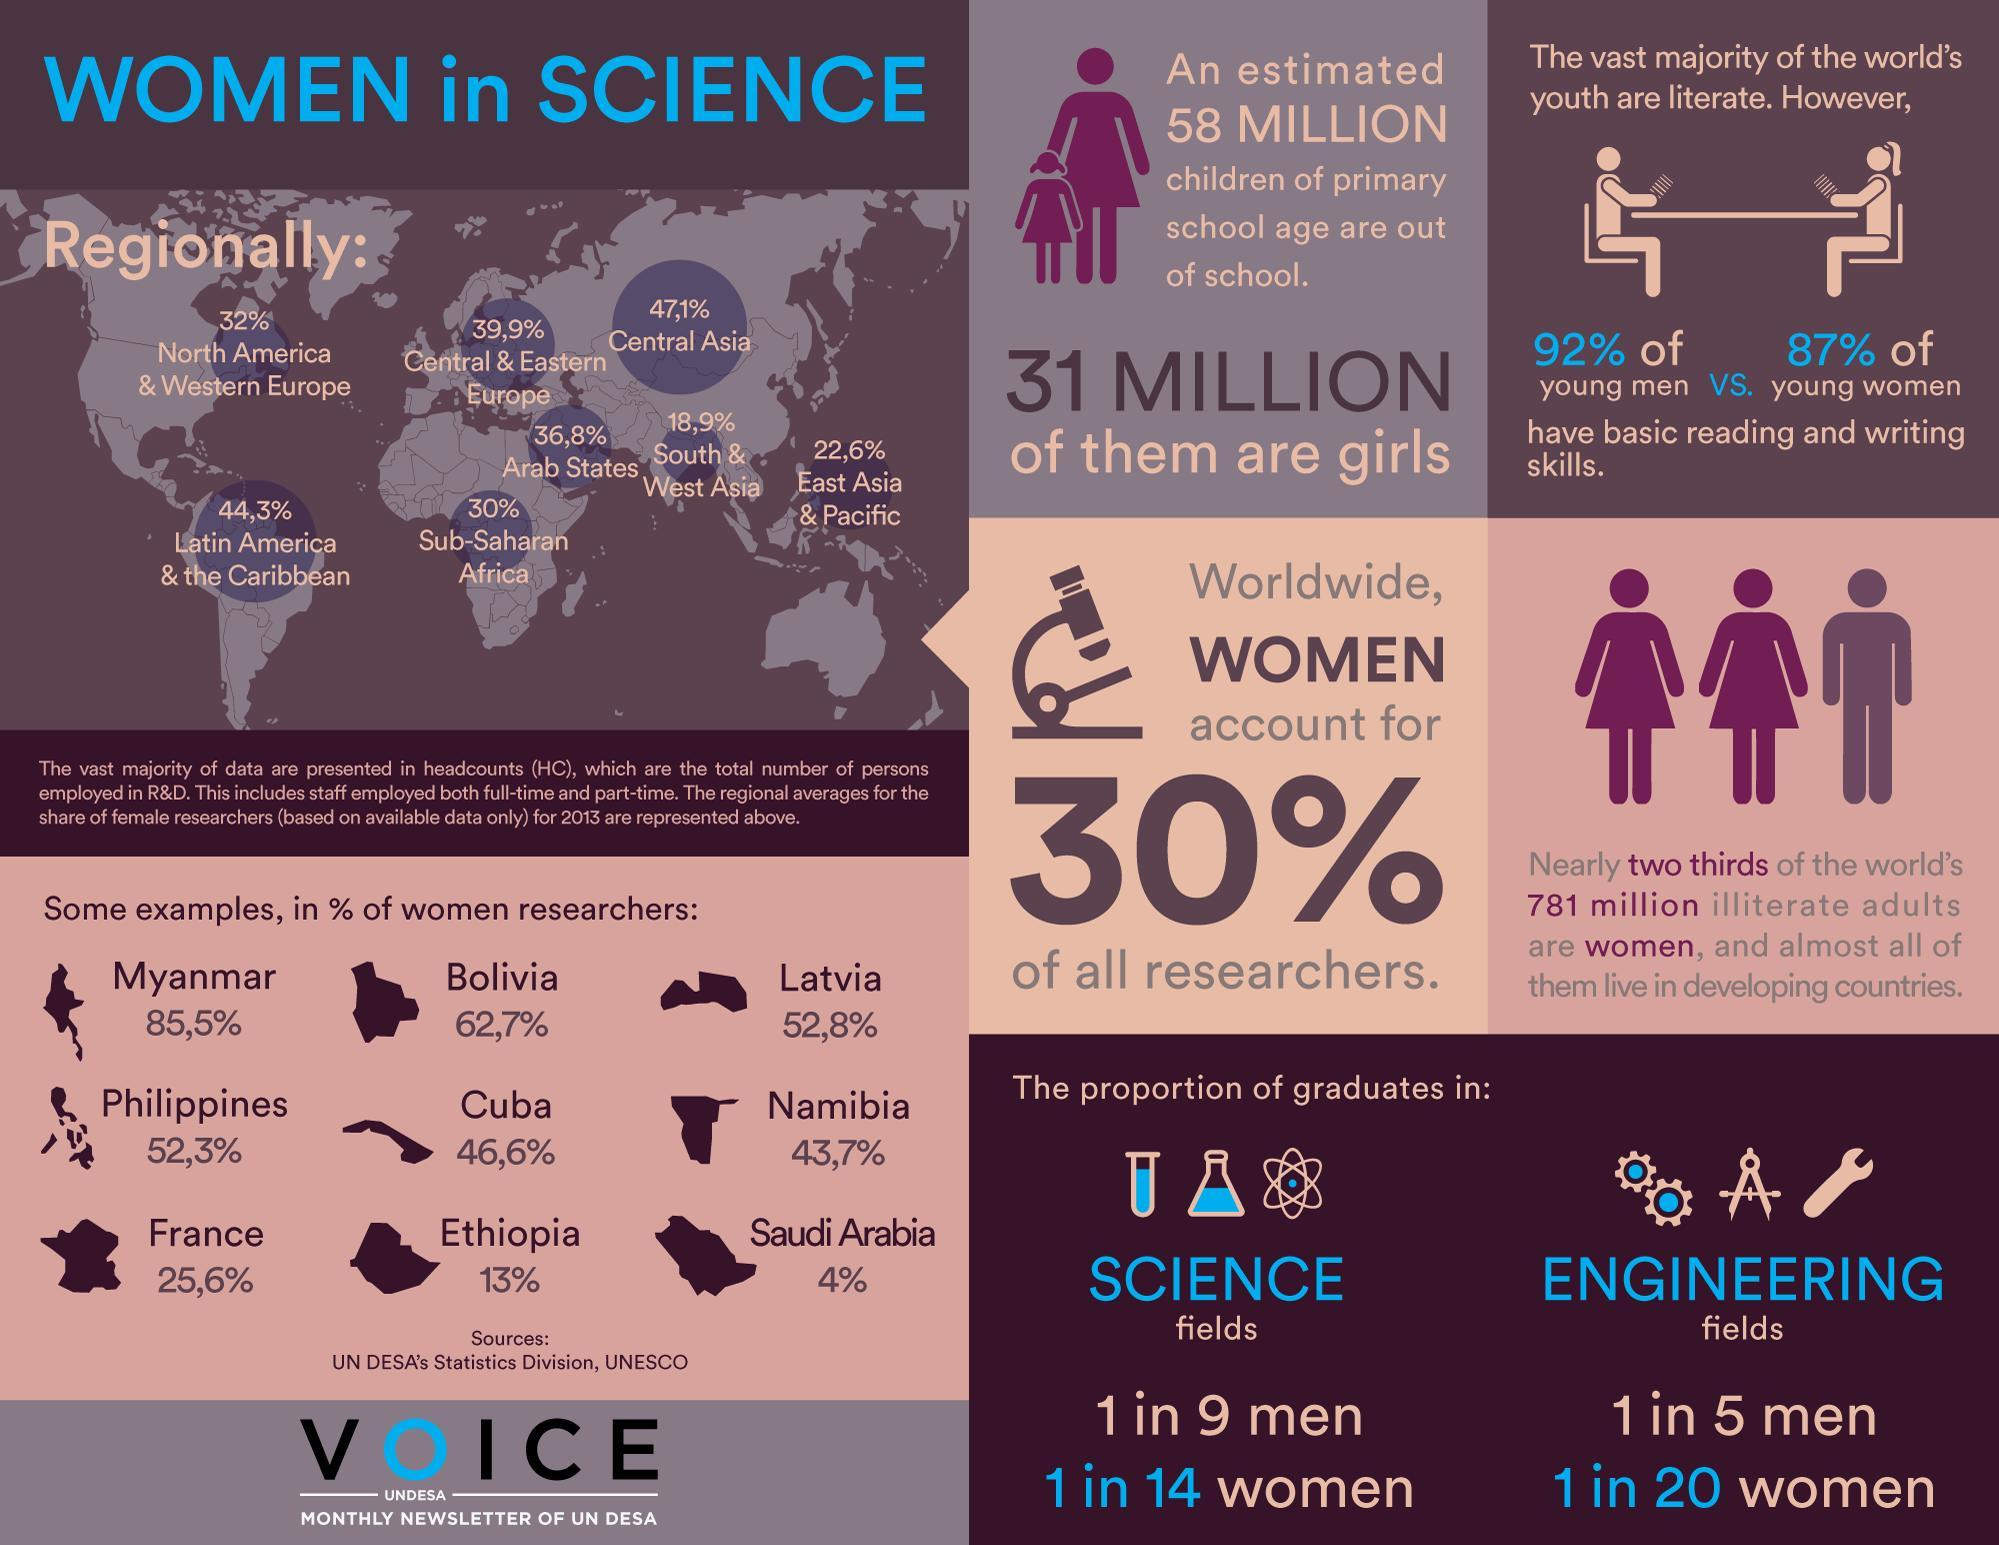What is the number of boys that are out of primary school ?
Answer the question with a short phrase. 27 million What is percentage gap in the young men and women who are literate? 5% Which country has the second lowest percentage of women researcher  among the countries Bolivia, Cuba, and Ethiopia ? Cuba What is the percentage of women researchers in Latvia 85.5%, 52.8%, or 62.7% ? 52.8% What is percentage gap in the number of women researchers in Ethiopia and Saudi Arabia? 9% Which region has the lowest percentage of women in science? South & West Asia Which country has the highest number of women researchers among Phillipines, France, and Namibia? Phillipines What is percentage of males who are in the field of research? 70% 